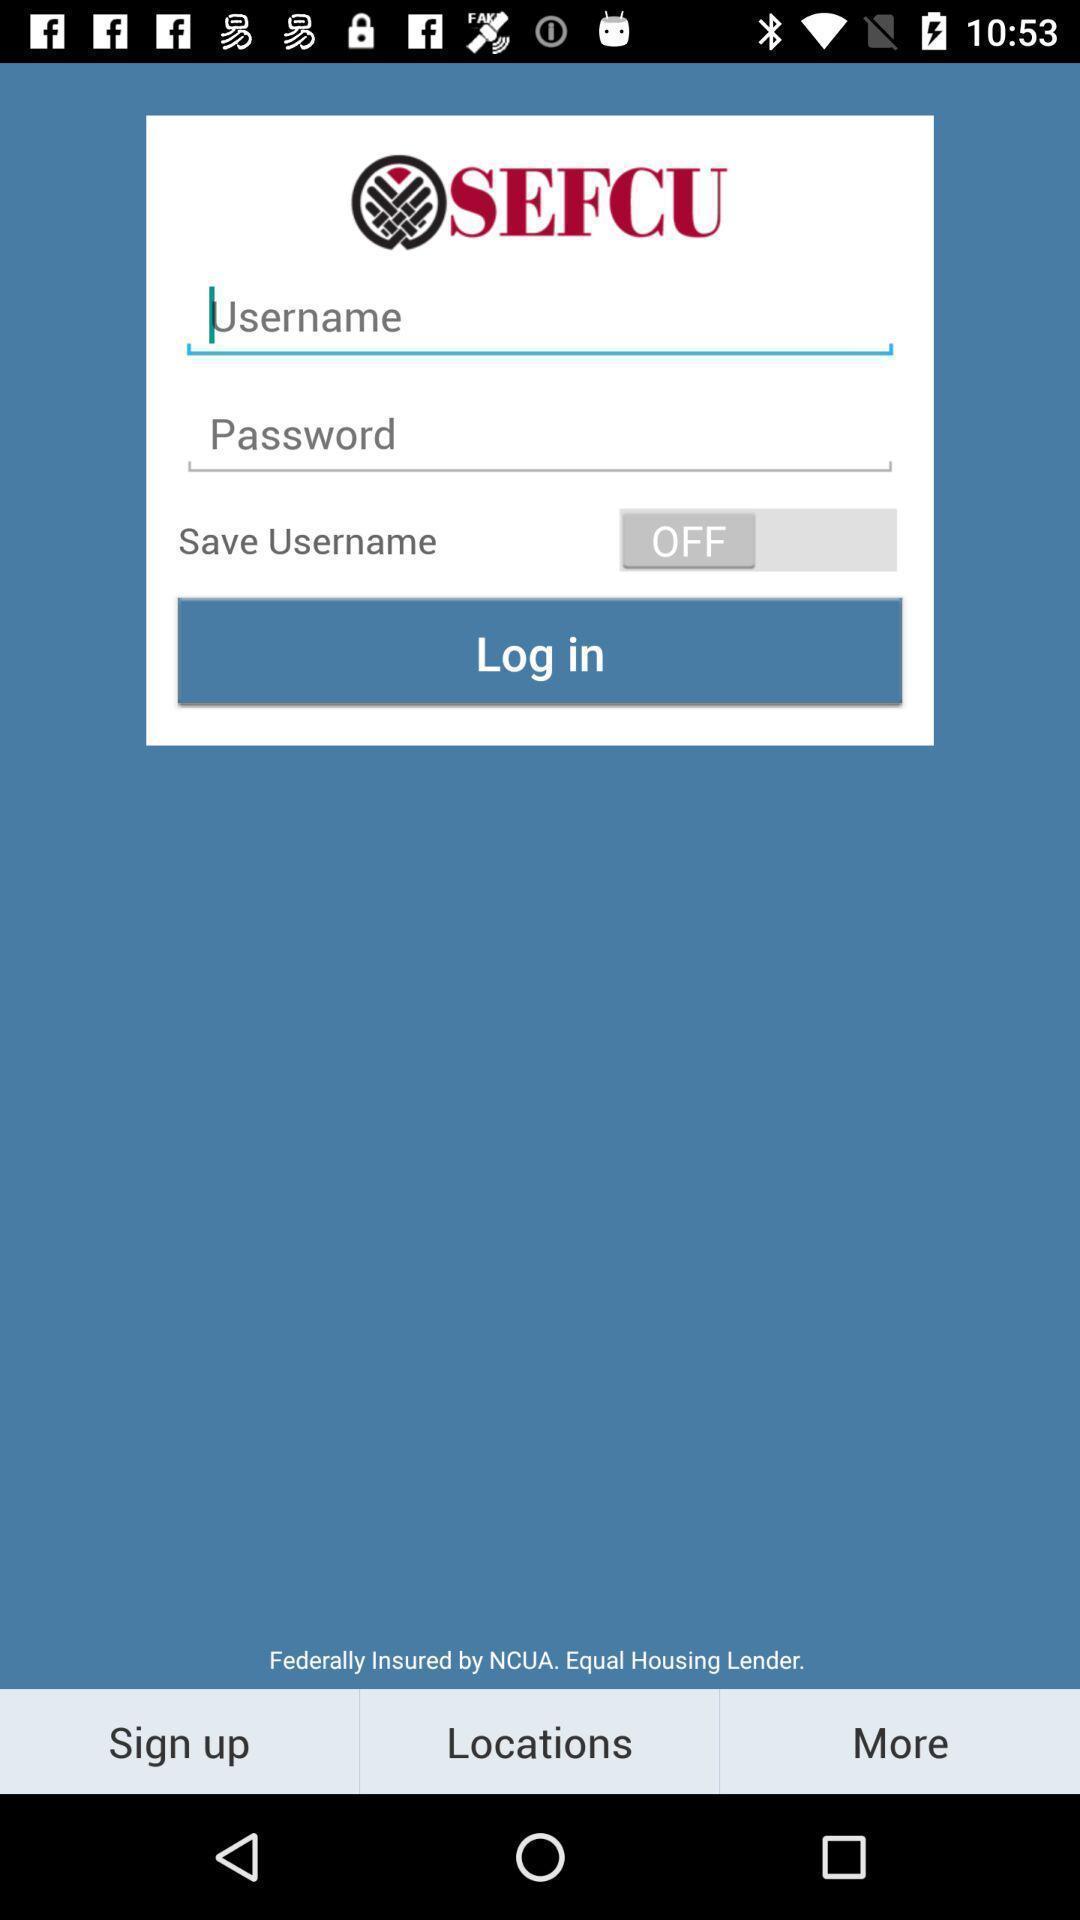What can you discern from this picture? Screen showing a login page of an account. 